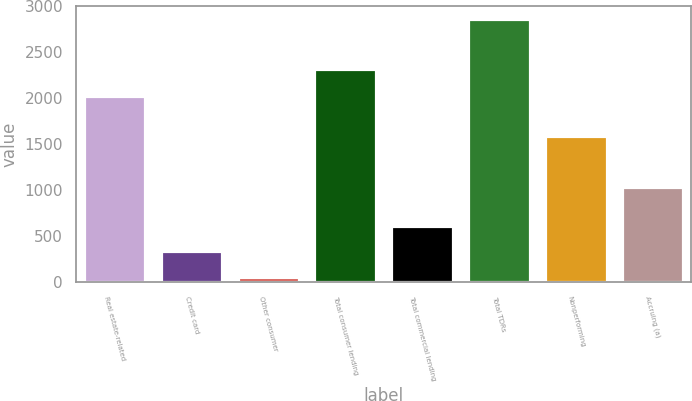<chart> <loc_0><loc_0><loc_500><loc_500><bar_chart><fcel>Real estate-related<fcel>Credit card<fcel>Other consumer<fcel>Total consumer lending<fcel>Total commercial lending<fcel>Total TDRs<fcel>Nonperforming<fcel>Accruing (a)<nl><fcel>2028<fcel>337.2<fcel>57<fcel>2318<fcel>617.4<fcel>2859<fcel>1589<fcel>1037<nl></chart> 